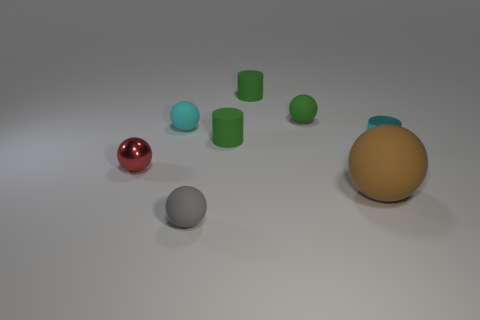Is there a pattern or theme to the arrangement of these objects? The arrangement does not suggest a specific pattern at first glance. It looks somewhat random, with objects scattered across the surface. However, the spatial distribution does allow each object to be distinct and noticeable, which might indicate a deliberate attempt to showcase a variety of shapes and materials without a particular order. 